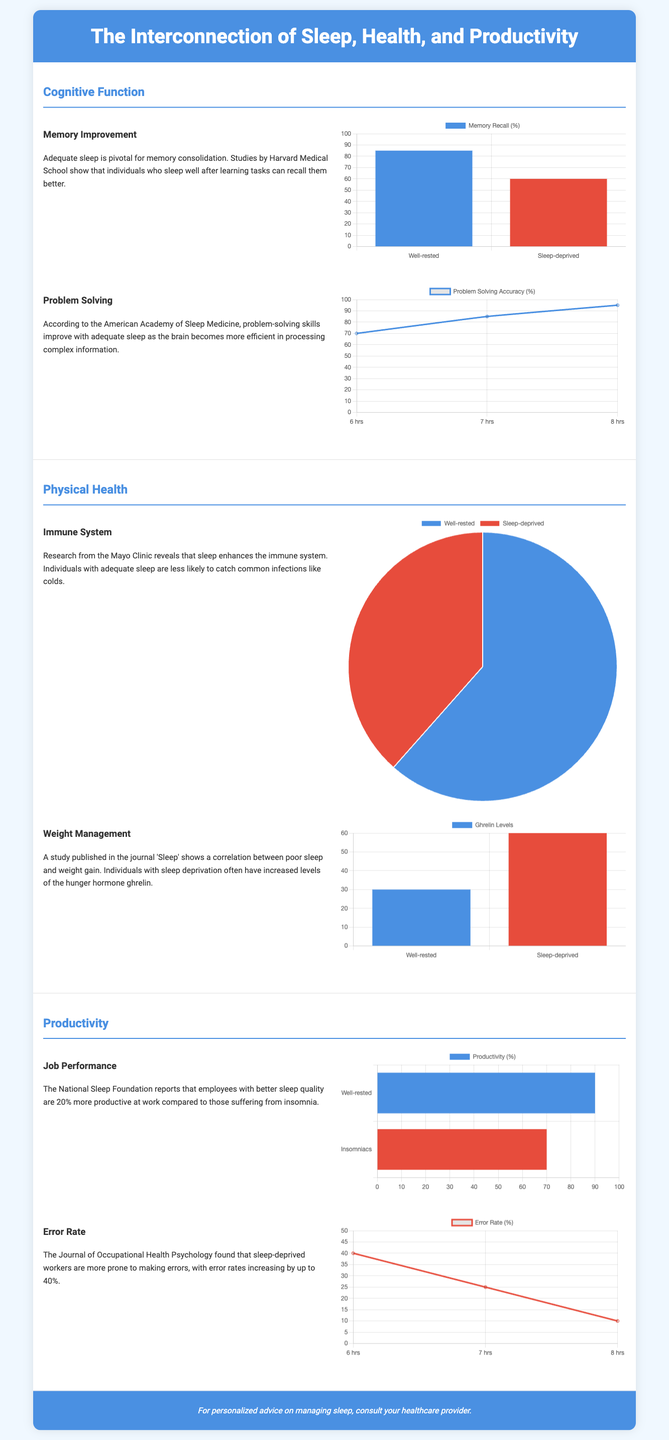What percentage of memory recall is observed in well-rested individuals? The percentage of memory recall for well-rested individuals is presented in the memory improvement chart, which shows 85%.
Answer: 85% What is the effect of sleep deprivation on problem-solving accuracy at 7 hours of sleep? The problem-solving chart indicates that problem-solving accuracy at 7 hours of sleep is 85%.
Answer: 85% What do well-rested individuals experience regarding immune system effectiveness? The pie chart displays that 80% of well-rested individuals have better immune system effectiveness compared to 50% of sleep-deprived individuals.
Answer: 80% What is the gherlin levels difference between well-rested and sleep-deprived individuals? The weight management chart reveals that well-rested individuals have 30 gherlin level units, while sleep-deprived individuals have 60.
Answer: 30 How much more productive are well-rested employees compared to insomniacs? According to the job performance chart, well-rested employees are 20% more productive than those suffering from insomnia.
Answer: 20% What does the error rate decrease to with 8 hours of sleep? The error rate chart shows that with 8 hours of sleep, the error rate decreases to 10%.
Answer: 10% How many hours of sleep correspond to the highest problem-solving accuracy? The problem-solving chart indicates that 8 hours of sleep corresponds to the highest problem-solving accuracy.
Answer: 8 hours What is the maximum error rate percentage shown in the document? The maximum error rate percentage presented in the error rate chart is 40%.
Answer: 40% What color represents sleep-deprived individuals in the charts? The color red is used to represent sleep-deprived individuals in the various charts.
Answer: Red 